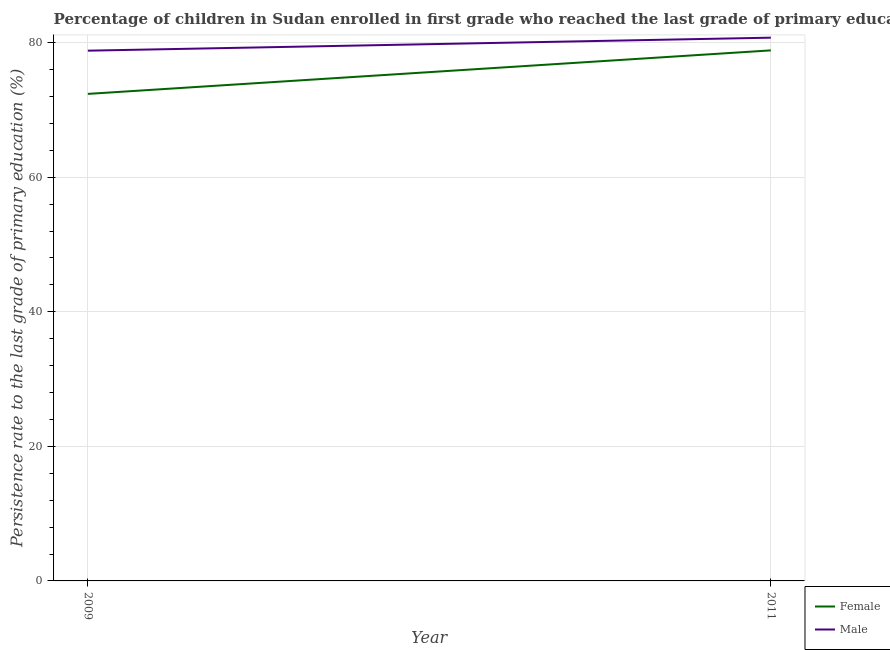How many different coloured lines are there?
Provide a short and direct response. 2. Does the line corresponding to persistence rate of male students intersect with the line corresponding to persistence rate of female students?
Offer a very short reply. No. What is the persistence rate of male students in 2011?
Your answer should be very brief. 80.74. Across all years, what is the maximum persistence rate of female students?
Ensure brevity in your answer.  78.85. Across all years, what is the minimum persistence rate of female students?
Offer a terse response. 72.38. In which year was the persistence rate of male students maximum?
Ensure brevity in your answer.  2011. In which year was the persistence rate of male students minimum?
Provide a short and direct response. 2009. What is the total persistence rate of male students in the graph?
Ensure brevity in your answer.  159.54. What is the difference between the persistence rate of male students in 2009 and that in 2011?
Make the answer very short. -1.93. What is the difference between the persistence rate of male students in 2011 and the persistence rate of female students in 2009?
Keep it short and to the point. 8.36. What is the average persistence rate of male students per year?
Provide a succinct answer. 79.77. In the year 2011, what is the difference between the persistence rate of female students and persistence rate of male students?
Make the answer very short. -1.89. What is the ratio of the persistence rate of male students in 2009 to that in 2011?
Offer a terse response. 0.98. In how many years, is the persistence rate of female students greater than the average persistence rate of female students taken over all years?
Offer a very short reply. 1. Does the persistence rate of female students monotonically increase over the years?
Ensure brevity in your answer.  Yes. Is the persistence rate of male students strictly greater than the persistence rate of female students over the years?
Your answer should be compact. Yes. How many years are there in the graph?
Your answer should be compact. 2. Does the graph contain grids?
Provide a succinct answer. Yes. How many legend labels are there?
Give a very brief answer. 2. How are the legend labels stacked?
Provide a succinct answer. Vertical. What is the title of the graph?
Provide a short and direct response. Percentage of children in Sudan enrolled in first grade who reached the last grade of primary education. Does "Taxes on profits and capital gains" appear as one of the legend labels in the graph?
Make the answer very short. No. What is the label or title of the Y-axis?
Keep it short and to the point. Persistence rate to the last grade of primary education (%). What is the Persistence rate to the last grade of primary education (%) of Female in 2009?
Your answer should be very brief. 72.38. What is the Persistence rate to the last grade of primary education (%) in Male in 2009?
Provide a succinct answer. 78.81. What is the Persistence rate to the last grade of primary education (%) in Female in 2011?
Keep it short and to the point. 78.85. What is the Persistence rate to the last grade of primary education (%) in Male in 2011?
Provide a short and direct response. 80.74. Across all years, what is the maximum Persistence rate to the last grade of primary education (%) in Female?
Offer a terse response. 78.85. Across all years, what is the maximum Persistence rate to the last grade of primary education (%) in Male?
Keep it short and to the point. 80.74. Across all years, what is the minimum Persistence rate to the last grade of primary education (%) of Female?
Provide a short and direct response. 72.38. Across all years, what is the minimum Persistence rate to the last grade of primary education (%) of Male?
Your answer should be compact. 78.81. What is the total Persistence rate to the last grade of primary education (%) of Female in the graph?
Provide a succinct answer. 151.23. What is the total Persistence rate to the last grade of primary education (%) of Male in the graph?
Provide a succinct answer. 159.54. What is the difference between the Persistence rate to the last grade of primary education (%) in Female in 2009 and that in 2011?
Keep it short and to the point. -6.47. What is the difference between the Persistence rate to the last grade of primary education (%) in Male in 2009 and that in 2011?
Give a very brief answer. -1.93. What is the difference between the Persistence rate to the last grade of primary education (%) of Female in 2009 and the Persistence rate to the last grade of primary education (%) of Male in 2011?
Ensure brevity in your answer.  -8.36. What is the average Persistence rate to the last grade of primary education (%) of Female per year?
Your answer should be compact. 75.62. What is the average Persistence rate to the last grade of primary education (%) in Male per year?
Keep it short and to the point. 79.77. In the year 2009, what is the difference between the Persistence rate to the last grade of primary education (%) in Female and Persistence rate to the last grade of primary education (%) in Male?
Ensure brevity in your answer.  -6.42. In the year 2011, what is the difference between the Persistence rate to the last grade of primary education (%) of Female and Persistence rate to the last grade of primary education (%) of Male?
Make the answer very short. -1.89. What is the ratio of the Persistence rate to the last grade of primary education (%) of Female in 2009 to that in 2011?
Offer a very short reply. 0.92. What is the ratio of the Persistence rate to the last grade of primary education (%) of Male in 2009 to that in 2011?
Make the answer very short. 0.98. What is the difference between the highest and the second highest Persistence rate to the last grade of primary education (%) of Female?
Offer a very short reply. 6.47. What is the difference between the highest and the second highest Persistence rate to the last grade of primary education (%) in Male?
Your answer should be very brief. 1.93. What is the difference between the highest and the lowest Persistence rate to the last grade of primary education (%) of Female?
Ensure brevity in your answer.  6.47. What is the difference between the highest and the lowest Persistence rate to the last grade of primary education (%) of Male?
Offer a terse response. 1.93. 